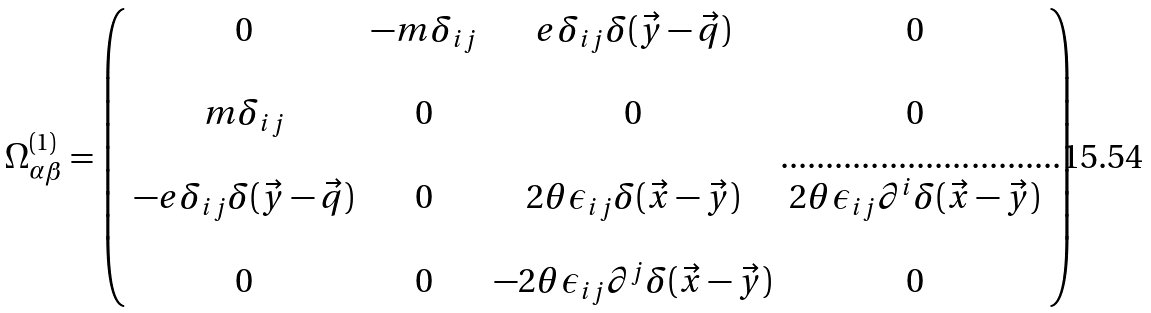<formula> <loc_0><loc_0><loc_500><loc_500>\Omega ^ { ( 1 ) } _ { \alpha \beta } = \left ( \begin{array} { c c c c } 0 & - m \delta _ { i j } & e \delta _ { i j } \delta ( \vec { y } - \vec { q } ) & 0 \\ \\ m \delta _ { i j } & 0 & 0 & 0 \\ \\ - e \delta _ { i j } \delta ( \vec { y } - \vec { q } ) & 0 & 2 \theta \epsilon _ { i j } \delta ( \vec { x } - \vec { y } ) & 2 \theta \epsilon _ { i j } \partial ^ { i } \delta ( \vec { x } - \vec { y } ) \\ \\ 0 & 0 & - 2 \theta \epsilon _ { i j } \partial ^ { j } \delta ( \vec { x } - \vec { y } ) & 0 \end{array} \right )</formula> 